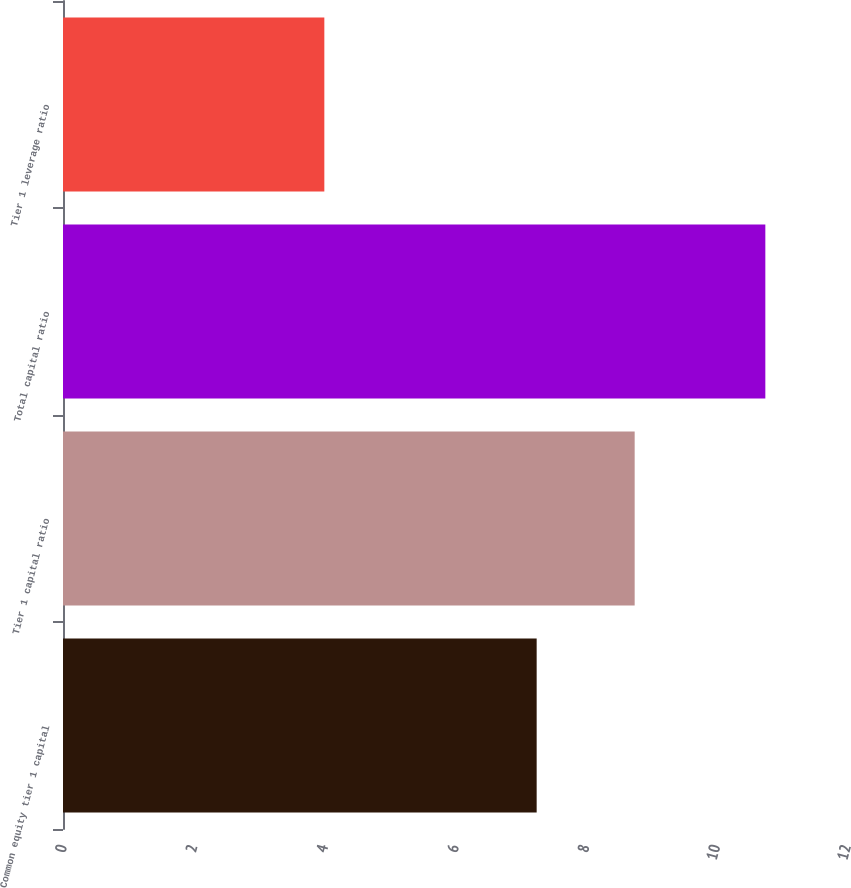Convert chart to OTSL. <chart><loc_0><loc_0><loc_500><loc_500><bar_chart><fcel>Common equity tier 1 capital<fcel>Tier 1 capital ratio<fcel>Total capital ratio<fcel>Tier 1 leverage ratio<nl><fcel>7.25<fcel>8.75<fcel>10.75<fcel>4<nl></chart> 